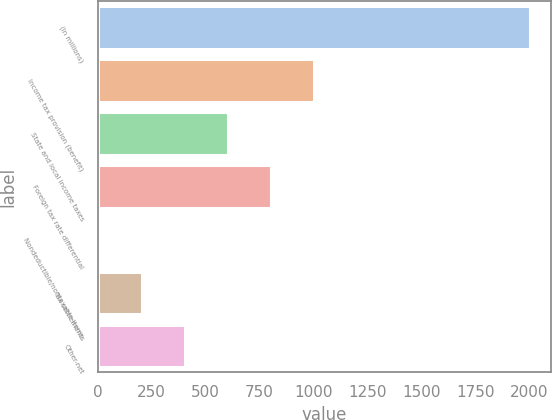Convert chart to OTSL. <chart><loc_0><loc_0><loc_500><loc_500><bar_chart><fcel>(In millions)<fcel>Income tax provision (benefit)<fcel>State and local income taxes<fcel>Foreign tax rate differential<fcel>Nondeductible/nontaxable items<fcel>Tax settlements<fcel>Other-net<nl><fcel>2004<fcel>1003.5<fcel>603.3<fcel>803.4<fcel>3<fcel>203.1<fcel>403.2<nl></chart> 